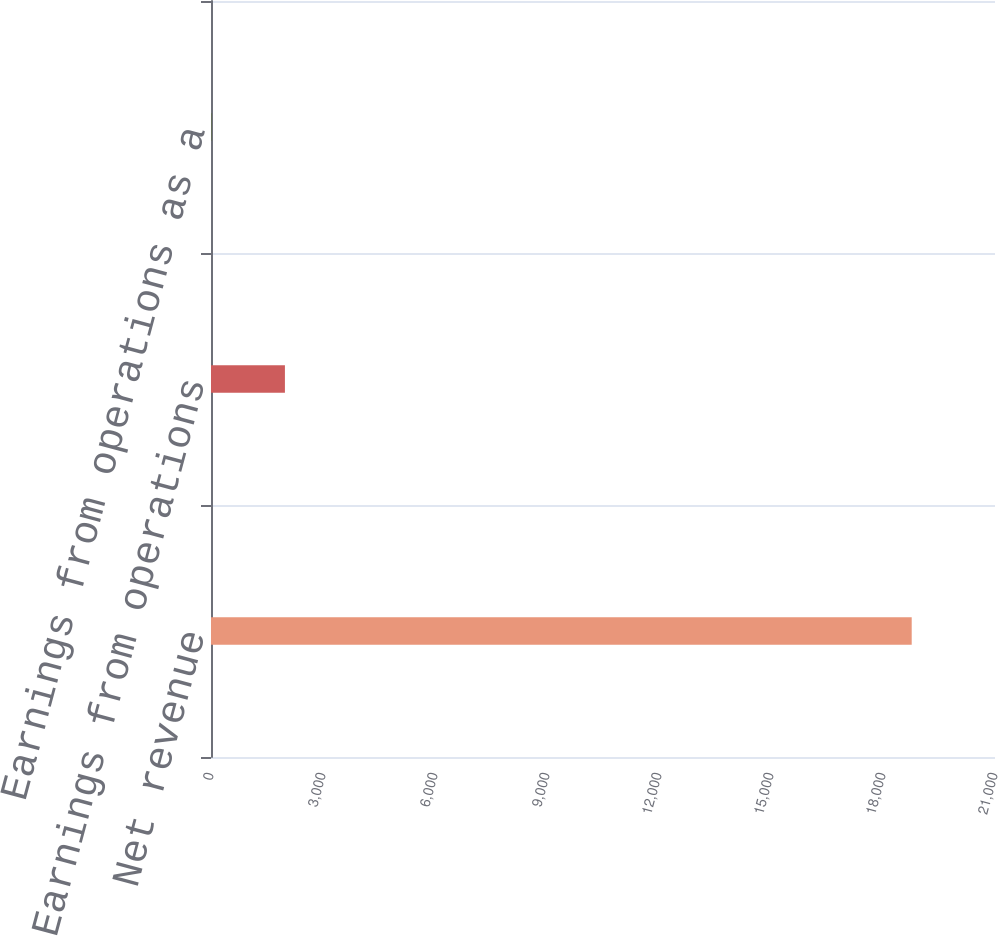Convert chart to OTSL. <chart><loc_0><loc_0><loc_500><loc_500><bar_chart><fcel>Net revenue<fcel>Earnings from operations<fcel>Earnings from operations as a<nl><fcel>18769<fcel>1980<fcel>10.5<nl></chart> 